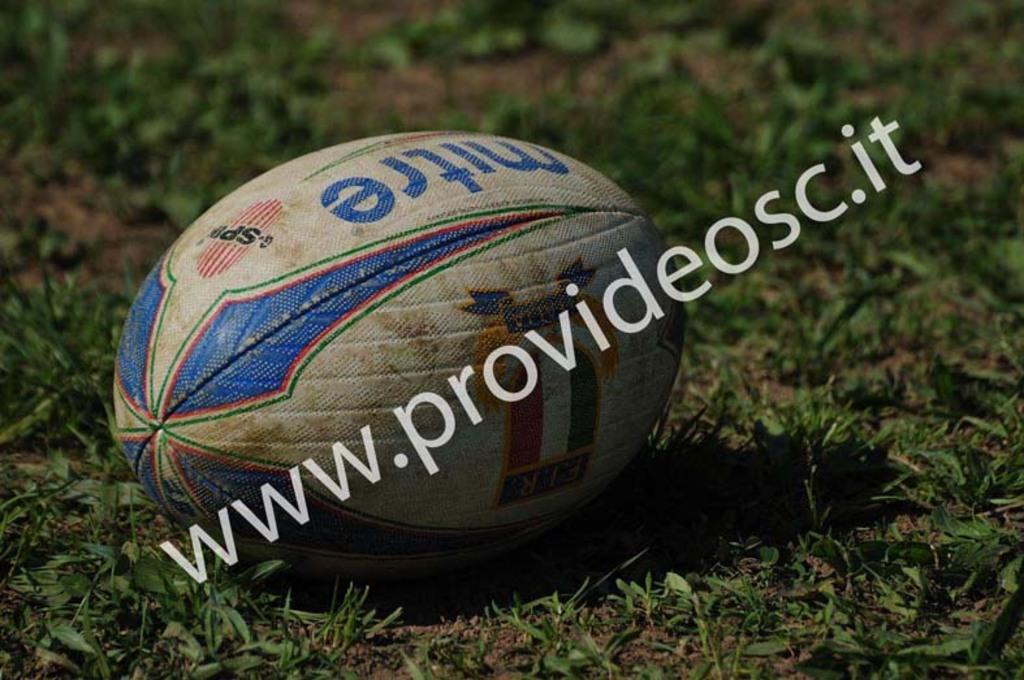What object is present on the green grass in the image? There is a ball on the green grass in the image. What type of surface is the ball resting on? The ball is resting on green grass in the image. What type of pie is being served on the grass in the image? There is no pie present in the image; it only features a ball on green grass. 